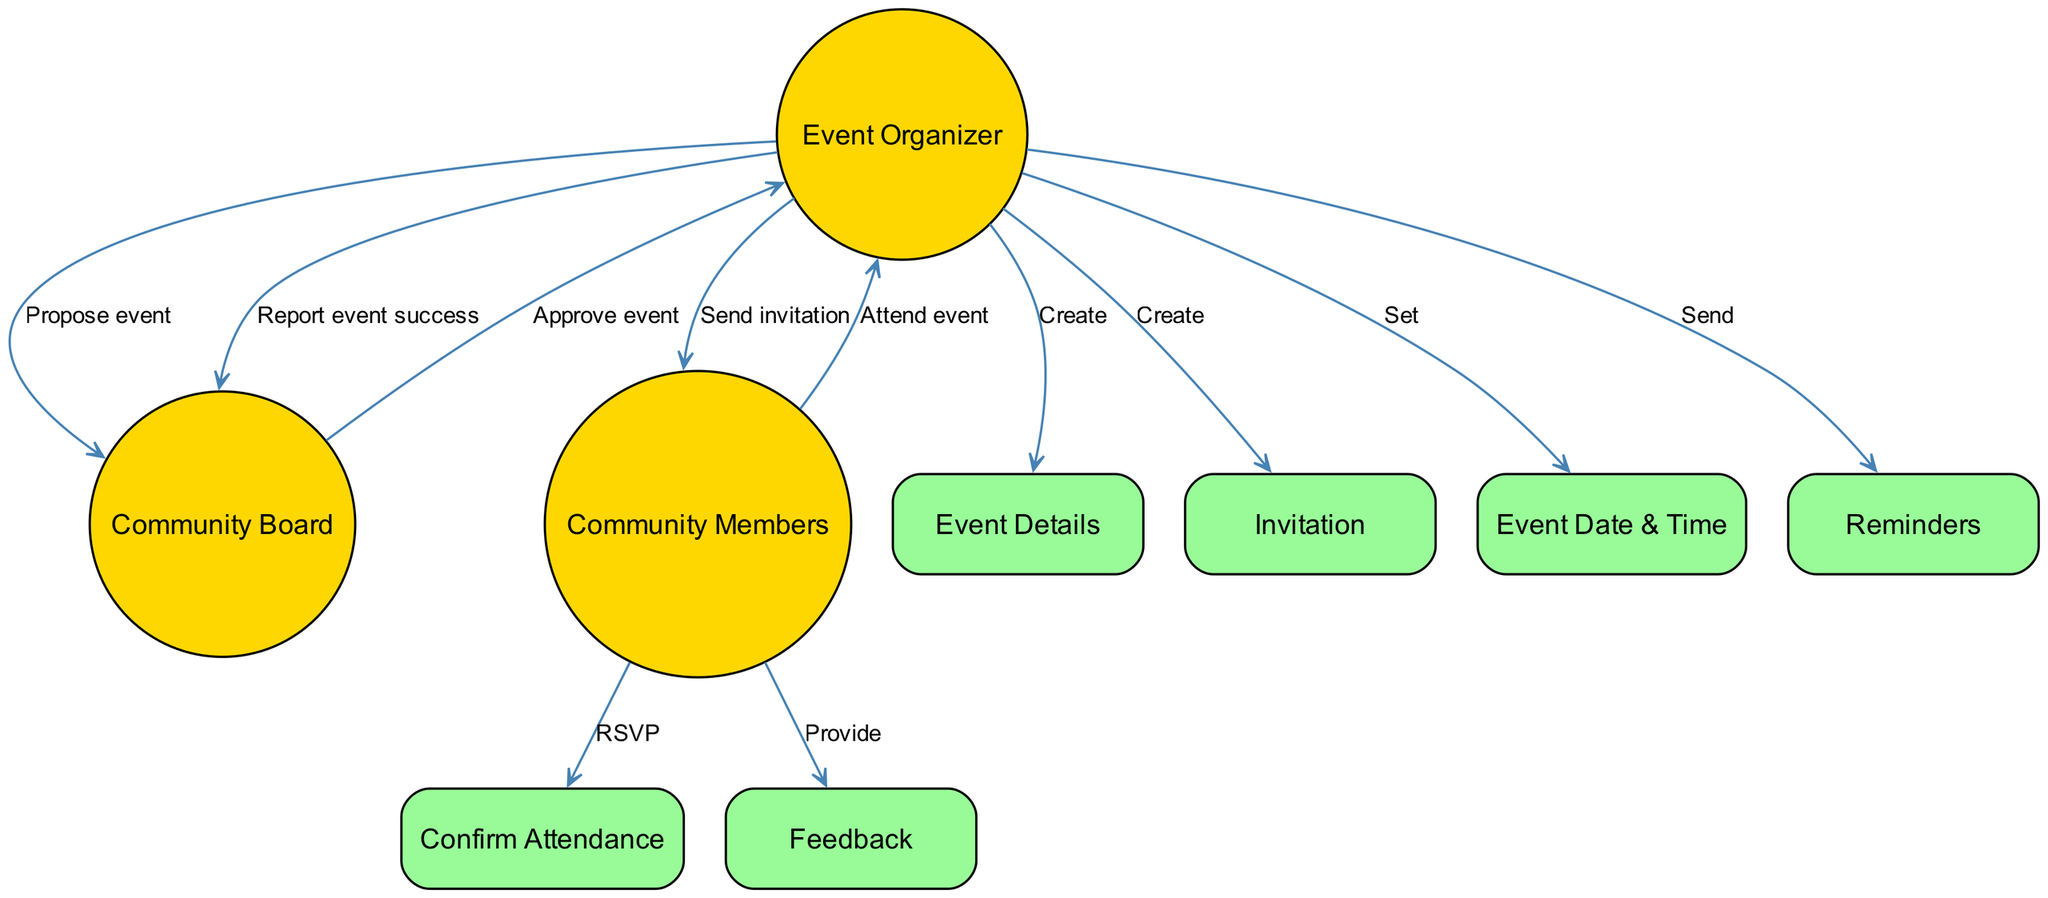What is the first action taken by the Event Organizer? The first action taken by the Event Organizer in the sequence is "Propose event." This is indicated by the arrow from the Event Organizer to the Community Board labeled with this action.
Answer: Propose event How many actors are involved in the sequence diagram? In the diagram, there are three actors: Event Organizer, Community Board, and Community Members. Each actor is represented by a circle, which totals to three.
Answer: Three What does the Event Organizer send to the Community Members? The Event Organizer sends an "Invitation" to the Community Members, as shown by the arrow directed from the Event Organizer to Community Members labeled "Send invitation."
Answer: Invitation Who provides feedback after the event? The "Community Members" provide feedback after the event. This is indicated by the arrow pointing from Community Members to the Feedback object labeled "Provide."
Answer: Community Members What is the last action in the sequence performed by the Event Organizer? The last action performed by the Event Organizer is "Report event success." This can be identified by the final arrow leading from the Event Organizer to Community Board.
Answer: Report event success How does the Community Board respond after the event is proposed? The Community Board responds by approving the event, as indicated by the arrow from the Community Board to the Event Organizer labeled "Approve event."
Answer: Approve event What do Community Members do after receiving an invitation? After receiving the invitation, Community Members "RSVP," which is represented by the interaction where they confirm their attendance back to the Event Organizer.
Answer: RSVP How many objects are present in the diagram? There are six objects depicted in the diagram: Event Details, Invitation, Confirm Attendance, Feedback, Event Date & Time, and Reminders, totaling six different objects.
Answer: Six What do the Event Organizer and Community Members do on the day of the event? On the day of the event, the Community Members "Attend event," which is represented by the action directed from Community Members to the Event Organizer.
Answer: Attend event 